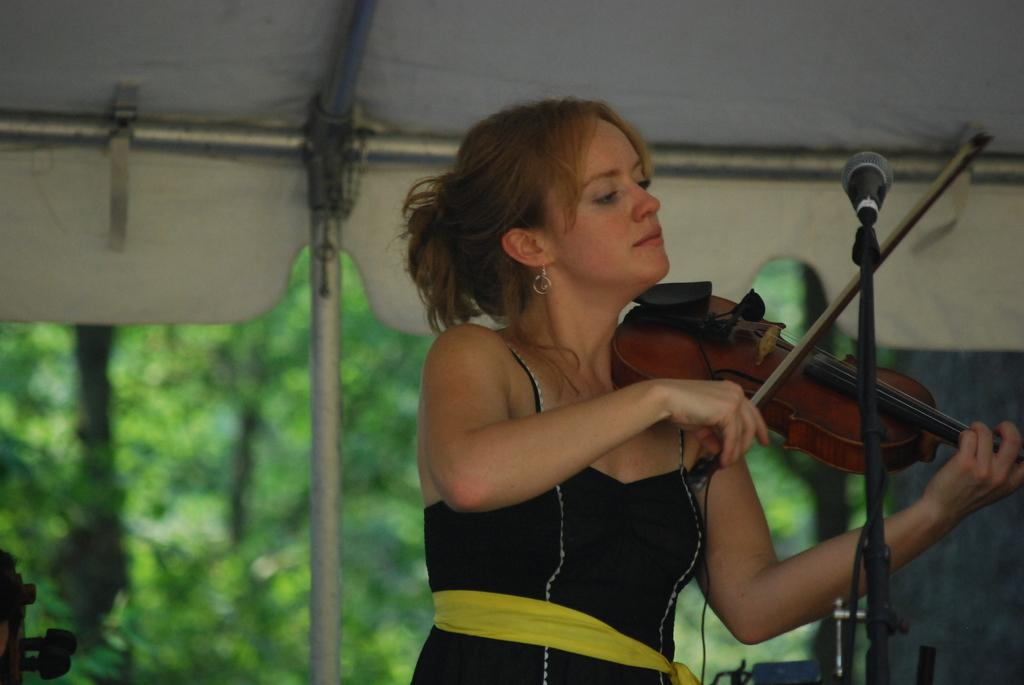Who is the main subject in the image? There is a woman in the image. What is the woman wearing? The woman is wearing a black dress. What is the woman holding in the image? The woman is holding a guitar. What can be seen in the background of the image? There are trees in the background of the image. How would you describe the background in the image? The background is slightly blurred. How many balls are visible in the image? There are no balls present in the image. What type of lettuce can be seen in the woman's hair in the image? There is no lettuce present in the image, nor is there any lettuce in the woman's hair. 